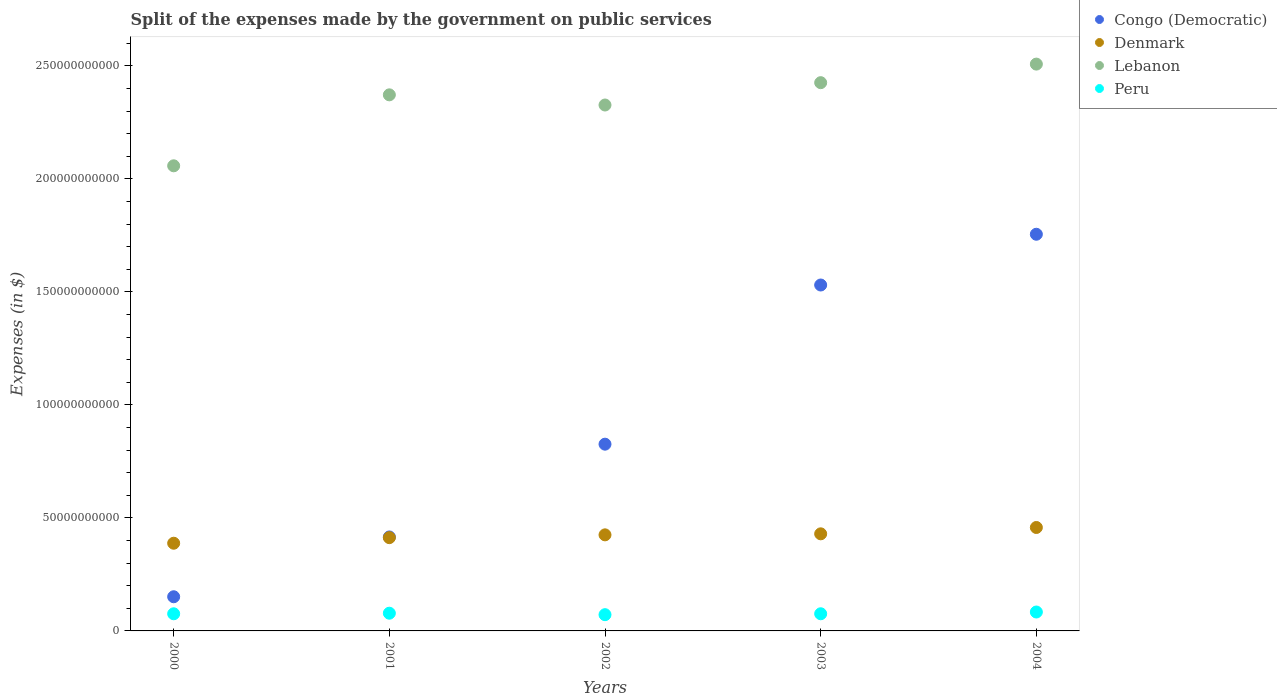Is the number of dotlines equal to the number of legend labels?
Your answer should be very brief. Yes. What is the expenses made by the government on public services in Lebanon in 2000?
Keep it short and to the point. 2.06e+11. Across all years, what is the maximum expenses made by the government on public services in Denmark?
Your response must be concise. 4.58e+1. Across all years, what is the minimum expenses made by the government on public services in Denmark?
Give a very brief answer. 3.88e+1. In which year was the expenses made by the government on public services in Peru minimum?
Your answer should be compact. 2002. What is the total expenses made by the government on public services in Lebanon in the graph?
Ensure brevity in your answer.  1.17e+12. What is the difference between the expenses made by the government on public services in Congo (Democratic) in 2000 and that in 2001?
Your answer should be very brief. -2.65e+1. What is the difference between the expenses made by the government on public services in Denmark in 2002 and the expenses made by the government on public services in Lebanon in 2003?
Keep it short and to the point. -2.00e+11. What is the average expenses made by the government on public services in Denmark per year?
Keep it short and to the point. 4.23e+1. In the year 2002, what is the difference between the expenses made by the government on public services in Congo (Democratic) and expenses made by the government on public services in Denmark?
Make the answer very short. 4.01e+1. What is the ratio of the expenses made by the government on public services in Peru in 2000 to that in 2004?
Ensure brevity in your answer.  0.91. Is the difference between the expenses made by the government on public services in Congo (Democratic) in 2000 and 2001 greater than the difference between the expenses made by the government on public services in Denmark in 2000 and 2001?
Provide a short and direct response. No. What is the difference between the highest and the second highest expenses made by the government on public services in Lebanon?
Give a very brief answer. 8.22e+09. What is the difference between the highest and the lowest expenses made by the government on public services in Peru?
Your answer should be very brief. 1.18e+09. In how many years, is the expenses made by the government on public services in Peru greater than the average expenses made by the government on public services in Peru taken over all years?
Give a very brief answer. 2. Is the sum of the expenses made by the government on public services in Lebanon in 2000 and 2001 greater than the maximum expenses made by the government on public services in Peru across all years?
Your response must be concise. Yes. Does the expenses made by the government on public services in Congo (Democratic) monotonically increase over the years?
Provide a short and direct response. Yes. Is the expenses made by the government on public services in Peru strictly greater than the expenses made by the government on public services in Denmark over the years?
Your response must be concise. No. Is the expenses made by the government on public services in Denmark strictly less than the expenses made by the government on public services in Lebanon over the years?
Keep it short and to the point. Yes. How many years are there in the graph?
Provide a succinct answer. 5. Are the values on the major ticks of Y-axis written in scientific E-notation?
Offer a very short reply. No. Does the graph contain grids?
Your response must be concise. No. Where does the legend appear in the graph?
Your answer should be compact. Top right. How many legend labels are there?
Ensure brevity in your answer.  4. How are the legend labels stacked?
Your response must be concise. Vertical. What is the title of the graph?
Provide a short and direct response. Split of the expenses made by the government on public services. What is the label or title of the Y-axis?
Your answer should be very brief. Expenses (in $). What is the Expenses (in $) in Congo (Democratic) in 2000?
Ensure brevity in your answer.  1.51e+1. What is the Expenses (in $) of Denmark in 2000?
Keep it short and to the point. 3.88e+1. What is the Expenses (in $) in Lebanon in 2000?
Provide a succinct answer. 2.06e+11. What is the Expenses (in $) of Peru in 2000?
Offer a very short reply. 7.58e+09. What is the Expenses (in $) of Congo (Democratic) in 2001?
Your answer should be compact. 4.16e+1. What is the Expenses (in $) of Denmark in 2001?
Keep it short and to the point. 4.13e+1. What is the Expenses (in $) in Lebanon in 2001?
Give a very brief answer. 2.37e+11. What is the Expenses (in $) in Peru in 2001?
Give a very brief answer. 7.84e+09. What is the Expenses (in $) of Congo (Democratic) in 2002?
Keep it short and to the point. 8.26e+1. What is the Expenses (in $) of Denmark in 2002?
Your answer should be compact. 4.25e+1. What is the Expenses (in $) of Lebanon in 2002?
Give a very brief answer. 2.33e+11. What is the Expenses (in $) in Peru in 2002?
Your answer should be very brief. 7.19e+09. What is the Expenses (in $) of Congo (Democratic) in 2003?
Ensure brevity in your answer.  1.53e+11. What is the Expenses (in $) in Denmark in 2003?
Ensure brevity in your answer.  4.30e+1. What is the Expenses (in $) of Lebanon in 2003?
Offer a very short reply. 2.43e+11. What is the Expenses (in $) of Peru in 2003?
Offer a terse response. 7.59e+09. What is the Expenses (in $) in Congo (Democratic) in 2004?
Make the answer very short. 1.76e+11. What is the Expenses (in $) in Denmark in 2004?
Ensure brevity in your answer.  4.58e+1. What is the Expenses (in $) of Lebanon in 2004?
Provide a short and direct response. 2.51e+11. What is the Expenses (in $) in Peru in 2004?
Your response must be concise. 8.37e+09. Across all years, what is the maximum Expenses (in $) in Congo (Democratic)?
Your response must be concise. 1.76e+11. Across all years, what is the maximum Expenses (in $) of Denmark?
Ensure brevity in your answer.  4.58e+1. Across all years, what is the maximum Expenses (in $) in Lebanon?
Offer a very short reply. 2.51e+11. Across all years, what is the maximum Expenses (in $) of Peru?
Provide a succinct answer. 8.37e+09. Across all years, what is the minimum Expenses (in $) in Congo (Democratic)?
Make the answer very short. 1.51e+1. Across all years, what is the minimum Expenses (in $) in Denmark?
Provide a succinct answer. 3.88e+1. Across all years, what is the minimum Expenses (in $) of Lebanon?
Provide a succinct answer. 2.06e+11. Across all years, what is the minimum Expenses (in $) in Peru?
Offer a terse response. 7.19e+09. What is the total Expenses (in $) in Congo (Democratic) in the graph?
Your answer should be very brief. 4.68e+11. What is the total Expenses (in $) of Denmark in the graph?
Your answer should be very brief. 2.11e+11. What is the total Expenses (in $) in Lebanon in the graph?
Provide a succinct answer. 1.17e+12. What is the total Expenses (in $) of Peru in the graph?
Provide a short and direct response. 3.86e+1. What is the difference between the Expenses (in $) of Congo (Democratic) in 2000 and that in 2001?
Offer a very short reply. -2.65e+1. What is the difference between the Expenses (in $) in Denmark in 2000 and that in 2001?
Offer a terse response. -2.47e+09. What is the difference between the Expenses (in $) in Lebanon in 2000 and that in 2001?
Ensure brevity in your answer.  -3.14e+1. What is the difference between the Expenses (in $) of Peru in 2000 and that in 2001?
Give a very brief answer. -2.54e+08. What is the difference between the Expenses (in $) in Congo (Democratic) in 2000 and that in 2002?
Offer a terse response. -6.75e+1. What is the difference between the Expenses (in $) in Denmark in 2000 and that in 2002?
Ensure brevity in your answer.  -3.71e+09. What is the difference between the Expenses (in $) of Lebanon in 2000 and that in 2002?
Your answer should be compact. -2.69e+1. What is the difference between the Expenses (in $) in Peru in 2000 and that in 2002?
Provide a short and direct response. 3.95e+08. What is the difference between the Expenses (in $) in Congo (Democratic) in 2000 and that in 2003?
Ensure brevity in your answer.  -1.38e+11. What is the difference between the Expenses (in $) in Denmark in 2000 and that in 2003?
Keep it short and to the point. -4.16e+09. What is the difference between the Expenses (in $) in Lebanon in 2000 and that in 2003?
Provide a short and direct response. -3.68e+1. What is the difference between the Expenses (in $) in Peru in 2000 and that in 2003?
Your answer should be compact. -6.50e+06. What is the difference between the Expenses (in $) of Congo (Democratic) in 2000 and that in 2004?
Provide a short and direct response. -1.60e+11. What is the difference between the Expenses (in $) of Denmark in 2000 and that in 2004?
Provide a succinct answer. -6.96e+09. What is the difference between the Expenses (in $) of Lebanon in 2000 and that in 2004?
Give a very brief answer. -4.50e+1. What is the difference between the Expenses (in $) in Peru in 2000 and that in 2004?
Offer a terse response. -7.84e+08. What is the difference between the Expenses (in $) in Congo (Democratic) in 2001 and that in 2002?
Provide a short and direct response. -4.11e+1. What is the difference between the Expenses (in $) in Denmark in 2001 and that in 2002?
Provide a short and direct response. -1.24e+09. What is the difference between the Expenses (in $) in Lebanon in 2001 and that in 2002?
Your response must be concise. 4.50e+09. What is the difference between the Expenses (in $) in Peru in 2001 and that in 2002?
Provide a short and direct response. 6.49e+08. What is the difference between the Expenses (in $) in Congo (Democratic) in 2001 and that in 2003?
Provide a short and direct response. -1.11e+11. What is the difference between the Expenses (in $) of Denmark in 2001 and that in 2003?
Provide a short and direct response. -1.69e+09. What is the difference between the Expenses (in $) of Lebanon in 2001 and that in 2003?
Give a very brief answer. -5.38e+09. What is the difference between the Expenses (in $) in Peru in 2001 and that in 2003?
Offer a very short reply. 2.48e+08. What is the difference between the Expenses (in $) of Congo (Democratic) in 2001 and that in 2004?
Ensure brevity in your answer.  -1.34e+11. What is the difference between the Expenses (in $) of Denmark in 2001 and that in 2004?
Offer a very short reply. -4.50e+09. What is the difference between the Expenses (in $) of Lebanon in 2001 and that in 2004?
Offer a very short reply. -1.36e+1. What is the difference between the Expenses (in $) in Peru in 2001 and that in 2004?
Make the answer very short. -5.30e+08. What is the difference between the Expenses (in $) of Congo (Democratic) in 2002 and that in 2003?
Your answer should be compact. -7.04e+1. What is the difference between the Expenses (in $) of Denmark in 2002 and that in 2003?
Ensure brevity in your answer.  -4.53e+08. What is the difference between the Expenses (in $) in Lebanon in 2002 and that in 2003?
Your answer should be very brief. -9.88e+09. What is the difference between the Expenses (in $) in Peru in 2002 and that in 2003?
Provide a succinct answer. -4.01e+08. What is the difference between the Expenses (in $) in Congo (Democratic) in 2002 and that in 2004?
Offer a very short reply. -9.29e+1. What is the difference between the Expenses (in $) in Denmark in 2002 and that in 2004?
Ensure brevity in your answer.  -3.26e+09. What is the difference between the Expenses (in $) of Lebanon in 2002 and that in 2004?
Ensure brevity in your answer.  -1.81e+1. What is the difference between the Expenses (in $) in Peru in 2002 and that in 2004?
Ensure brevity in your answer.  -1.18e+09. What is the difference between the Expenses (in $) of Congo (Democratic) in 2003 and that in 2004?
Provide a short and direct response. -2.25e+1. What is the difference between the Expenses (in $) of Denmark in 2003 and that in 2004?
Offer a terse response. -2.80e+09. What is the difference between the Expenses (in $) in Lebanon in 2003 and that in 2004?
Provide a short and direct response. -8.22e+09. What is the difference between the Expenses (in $) in Peru in 2003 and that in 2004?
Provide a short and direct response. -7.78e+08. What is the difference between the Expenses (in $) of Congo (Democratic) in 2000 and the Expenses (in $) of Denmark in 2001?
Provide a succinct answer. -2.62e+1. What is the difference between the Expenses (in $) in Congo (Democratic) in 2000 and the Expenses (in $) in Lebanon in 2001?
Keep it short and to the point. -2.22e+11. What is the difference between the Expenses (in $) of Congo (Democratic) in 2000 and the Expenses (in $) of Peru in 2001?
Ensure brevity in your answer.  7.28e+09. What is the difference between the Expenses (in $) of Denmark in 2000 and the Expenses (in $) of Lebanon in 2001?
Provide a succinct answer. -1.98e+11. What is the difference between the Expenses (in $) of Denmark in 2000 and the Expenses (in $) of Peru in 2001?
Give a very brief answer. 3.10e+1. What is the difference between the Expenses (in $) in Lebanon in 2000 and the Expenses (in $) in Peru in 2001?
Provide a short and direct response. 1.98e+11. What is the difference between the Expenses (in $) in Congo (Democratic) in 2000 and the Expenses (in $) in Denmark in 2002?
Your answer should be compact. -2.74e+1. What is the difference between the Expenses (in $) in Congo (Democratic) in 2000 and the Expenses (in $) in Lebanon in 2002?
Provide a succinct answer. -2.18e+11. What is the difference between the Expenses (in $) of Congo (Democratic) in 2000 and the Expenses (in $) of Peru in 2002?
Keep it short and to the point. 7.93e+09. What is the difference between the Expenses (in $) in Denmark in 2000 and the Expenses (in $) in Lebanon in 2002?
Keep it short and to the point. -1.94e+11. What is the difference between the Expenses (in $) of Denmark in 2000 and the Expenses (in $) of Peru in 2002?
Your response must be concise. 3.16e+1. What is the difference between the Expenses (in $) of Lebanon in 2000 and the Expenses (in $) of Peru in 2002?
Your response must be concise. 1.99e+11. What is the difference between the Expenses (in $) of Congo (Democratic) in 2000 and the Expenses (in $) of Denmark in 2003?
Ensure brevity in your answer.  -2.78e+1. What is the difference between the Expenses (in $) of Congo (Democratic) in 2000 and the Expenses (in $) of Lebanon in 2003?
Your answer should be very brief. -2.27e+11. What is the difference between the Expenses (in $) of Congo (Democratic) in 2000 and the Expenses (in $) of Peru in 2003?
Your response must be concise. 7.53e+09. What is the difference between the Expenses (in $) in Denmark in 2000 and the Expenses (in $) in Lebanon in 2003?
Your answer should be compact. -2.04e+11. What is the difference between the Expenses (in $) of Denmark in 2000 and the Expenses (in $) of Peru in 2003?
Provide a short and direct response. 3.12e+1. What is the difference between the Expenses (in $) in Lebanon in 2000 and the Expenses (in $) in Peru in 2003?
Your answer should be very brief. 1.98e+11. What is the difference between the Expenses (in $) in Congo (Democratic) in 2000 and the Expenses (in $) in Denmark in 2004?
Provide a short and direct response. -3.06e+1. What is the difference between the Expenses (in $) in Congo (Democratic) in 2000 and the Expenses (in $) in Lebanon in 2004?
Provide a succinct answer. -2.36e+11. What is the difference between the Expenses (in $) of Congo (Democratic) in 2000 and the Expenses (in $) of Peru in 2004?
Your answer should be very brief. 6.75e+09. What is the difference between the Expenses (in $) in Denmark in 2000 and the Expenses (in $) in Lebanon in 2004?
Provide a succinct answer. -2.12e+11. What is the difference between the Expenses (in $) of Denmark in 2000 and the Expenses (in $) of Peru in 2004?
Your answer should be compact. 3.04e+1. What is the difference between the Expenses (in $) of Lebanon in 2000 and the Expenses (in $) of Peru in 2004?
Offer a very short reply. 1.97e+11. What is the difference between the Expenses (in $) of Congo (Democratic) in 2001 and the Expenses (in $) of Denmark in 2002?
Offer a very short reply. -9.29e+08. What is the difference between the Expenses (in $) in Congo (Democratic) in 2001 and the Expenses (in $) in Lebanon in 2002?
Offer a terse response. -1.91e+11. What is the difference between the Expenses (in $) in Congo (Democratic) in 2001 and the Expenses (in $) in Peru in 2002?
Offer a very short reply. 3.44e+1. What is the difference between the Expenses (in $) of Denmark in 2001 and the Expenses (in $) of Lebanon in 2002?
Your answer should be very brief. -1.91e+11. What is the difference between the Expenses (in $) in Denmark in 2001 and the Expenses (in $) in Peru in 2002?
Keep it short and to the point. 3.41e+1. What is the difference between the Expenses (in $) of Lebanon in 2001 and the Expenses (in $) of Peru in 2002?
Give a very brief answer. 2.30e+11. What is the difference between the Expenses (in $) of Congo (Democratic) in 2001 and the Expenses (in $) of Denmark in 2003?
Make the answer very short. -1.38e+09. What is the difference between the Expenses (in $) in Congo (Democratic) in 2001 and the Expenses (in $) in Lebanon in 2003?
Your answer should be very brief. -2.01e+11. What is the difference between the Expenses (in $) in Congo (Democratic) in 2001 and the Expenses (in $) in Peru in 2003?
Provide a short and direct response. 3.40e+1. What is the difference between the Expenses (in $) in Denmark in 2001 and the Expenses (in $) in Lebanon in 2003?
Your response must be concise. -2.01e+11. What is the difference between the Expenses (in $) in Denmark in 2001 and the Expenses (in $) in Peru in 2003?
Your answer should be compact. 3.37e+1. What is the difference between the Expenses (in $) in Lebanon in 2001 and the Expenses (in $) in Peru in 2003?
Make the answer very short. 2.30e+11. What is the difference between the Expenses (in $) in Congo (Democratic) in 2001 and the Expenses (in $) in Denmark in 2004?
Provide a short and direct response. -4.19e+09. What is the difference between the Expenses (in $) in Congo (Democratic) in 2001 and the Expenses (in $) in Lebanon in 2004?
Offer a terse response. -2.09e+11. What is the difference between the Expenses (in $) in Congo (Democratic) in 2001 and the Expenses (in $) in Peru in 2004?
Make the answer very short. 3.32e+1. What is the difference between the Expenses (in $) of Denmark in 2001 and the Expenses (in $) of Lebanon in 2004?
Ensure brevity in your answer.  -2.10e+11. What is the difference between the Expenses (in $) of Denmark in 2001 and the Expenses (in $) of Peru in 2004?
Provide a short and direct response. 3.29e+1. What is the difference between the Expenses (in $) of Lebanon in 2001 and the Expenses (in $) of Peru in 2004?
Your response must be concise. 2.29e+11. What is the difference between the Expenses (in $) of Congo (Democratic) in 2002 and the Expenses (in $) of Denmark in 2003?
Your answer should be very brief. 3.97e+1. What is the difference between the Expenses (in $) of Congo (Democratic) in 2002 and the Expenses (in $) of Lebanon in 2003?
Provide a succinct answer. -1.60e+11. What is the difference between the Expenses (in $) in Congo (Democratic) in 2002 and the Expenses (in $) in Peru in 2003?
Your answer should be compact. 7.50e+1. What is the difference between the Expenses (in $) in Denmark in 2002 and the Expenses (in $) in Lebanon in 2003?
Keep it short and to the point. -2.00e+11. What is the difference between the Expenses (in $) of Denmark in 2002 and the Expenses (in $) of Peru in 2003?
Offer a terse response. 3.49e+1. What is the difference between the Expenses (in $) in Lebanon in 2002 and the Expenses (in $) in Peru in 2003?
Make the answer very short. 2.25e+11. What is the difference between the Expenses (in $) in Congo (Democratic) in 2002 and the Expenses (in $) in Denmark in 2004?
Provide a succinct answer. 3.69e+1. What is the difference between the Expenses (in $) of Congo (Democratic) in 2002 and the Expenses (in $) of Lebanon in 2004?
Ensure brevity in your answer.  -1.68e+11. What is the difference between the Expenses (in $) in Congo (Democratic) in 2002 and the Expenses (in $) in Peru in 2004?
Provide a short and direct response. 7.43e+1. What is the difference between the Expenses (in $) of Denmark in 2002 and the Expenses (in $) of Lebanon in 2004?
Your response must be concise. -2.08e+11. What is the difference between the Expenses (in $) of Denmark in 2002 and the Expenses (in $) of Peru in 2004?
Provide a succinct answer. 3.41e+1. What is the difference between the Expenses (in $) of Lebanon in 2002 and the Expenses (in $) of Peru in 2004?
Your answer should be compact. 2.24e+11. What is the difference between the Expenses (in $) in Congo (Democratic) in 2003 and the Expenses (in $) in Denmark in 2004?
Your answer should be very brief. 1.07e+11. What is the difference between the Expenses (in $) in Congo (Democratic) in 2003 and the Expenses (in $) in Lebanon in 2004?
Ensure brevity in your answer.  -9.77e+1. What is the difference between the Expenses (in $) of Congo (Democratic) in 2003 and the Expenses (in $) of Peru in 2004?
Ensure brevity in your answer.  1.45e+11. What is the difference between the Expenses (in $) in Denmark in 2003 and the Expenses (in $) in Lebanon in 2004?
Give a very brief answer. -2.08e+11. What is the difference between the Expenses (in $) in Denmark in 2003 and the Expenses (in $) in Peru in 2004?
Your response must be concise. 3.46e+1. What is the difference between the Expenses (in $) of Lebanon in 2003 and the Expenses (in $) of Peru in 2004?
Provide a short and direct response. 2.34e+11. What is the average Expenses (in $) in Congo (Democratic) per year?
Keep it short and to the point. 9.36e+1. What is the average Expenses (in $) of Denmark per year?
Offer a very short reply. 4.23e+1. What is the average Expenses (in $) of Lebanon per year?
Give a very brief answer. 2.34e+11. What is the average Expenses (in $) of Peru per year?
Ensure brevity in your answer.  7.71e+09. In the year 2000, what is the difference between the Expenses (in $) in Congo (Democratic) and Expenses (in $) in Denmark?
Your answer should be compact. -2.37e+1. In the year 2000, what is the difference between the Expenses (in $) in Congo (Democratic) and Expenses (in $) in Lebanon?
Provide a short and direct response. -1.91e+11. In the year 2000, what is the difference between the Expenses (in $) in Congo (Democratic) and Expenses (in $) in Peru?
Give a very brief answer. 7.53e+09. In the year 2000, what is the difference between the Expenses (in $) of Denmark and Expenses (in $) of Lebanon?
Provide a short and direct response. -1.67e+11. In the year 2000, what is the difference between the Expenses (in $) in Denmark and Expenses (in $) in Peru?
Your answer should be compact. 3.12e+1. In the year 2000, what is the difference between the Expenses (in $) in Lebanon and Expenses (in $) in Peru?
Offer a terse response. 1.98e+11. In the year 2001, what is the difference between the Expenses (in $) in Congo (Democratic) and Expenses (in $) in Denmark?
Give a very brief answer. 3.08e+08. In the year 2001, what is the difference between the Expenses (in $) of Congo (Democratic) and Expenses (in $) of Lebanon?
Offer a very short reply. -1.96e+11. In the year 2001, what is the difference between the Expenses (in $) of Congo (Democratic) and Expenses (in $) of Peru?
Ensure brevity in your answer.  3.37e+1. In the year 2001, what is the difference between the Expenses (in $) of Denmark and Expenses (in $) of Lebanon?
Offer a terse response. -1.96e+11. In the year 2001, what is the difference between the Expenses (in $) of Denmark and Expenses (in $) of Peru?
Provide a succinct answer. 3.34e+1. In the year 2001, what is the difference between the Expenses (in $) in Lebanon and Expenses (in $) in Peru?
Ensure brevity in your answer.  2.29e+11. In the year 2002, what is the difference between the Expenses (in $) in Congo (Democratic) and Expenses (in $) in Denmark?
Ensure brevity in your answer.  4.01e+1. In the year 2002, what is the difference between the Expenses (in $) of Congo (Democratic) and Expenses (in $) of Lebanon?
Your answer should be compact. -1.50e+11. In the year 2002, what is the difference between the Expenses (in $) of Congo (Democratic) and Expenses (in $) of Peru?
Your answer should be very brief. 7.54e+1. In the year 2002, what is the difference between the Expenses (in $) of Denmark and Expenses (in $) of Lebanon?
Your answer should be compact. -1.90e+11. In the year 2002, what is the difference between the Expenses (in $) in Denmark and Expenses (in $) in Peru?
Give a very brief answer. 3.53e+1. In the year 2002, what is the difference between the Expenses (in $) of Lebanon and Expenses (in $) of Peru?
Ensure brevity in your answer.  2.26e+11. In the year 2003, what is the difference between the Expenses (in $) in Congo (Democratic) and Expenses (in $) in Denmark?
Offer a terse response. 1.10e+11. In the year 2003, what is the difference between the Expenses (in $) of Congo (Democratic) and Expenses (in $) of Lebanon?
Provide a short and direct response. -8.95e+1. In the year 2003, what is the difference between the Expenses (in $) in Congo (Democratic) and Expenses (in $) in Peru?
Provide a succinct answer. 1.45e+11. In the year 2003, what is the difference between the Expenses (in $) in Denmark and Expenses (in $) in Lebanon?
Give a very brief answer. -2.00e+11. In the year 2003, what is the difference between the Expenses (in $) in Denmark and Expenses (in $) in Peru?
Your answer should be compact. 3.54e+1. In the year 2003, what is the difference between the Expenses (in $) in Lebanon and Expenses (in $) in Peru?
Make the answer very short. 2.35e+11. In the year 2004, what is the difference between the Expenses (in $) of Congo (Democratic) and Expenses (in $) of Denmark?
Your response must be concise. 1.30e+11. In the year 2004, what is the difference between the Expenses (in $) of Congo (Democratic) and Expenses (in $) of Lebanon?
Provide a succinct answer. -7.53e+1. In the year 2004, what is the difference between the Expenses (in $) in Congo (Democratic) and Expenses (in $) in Peru?
Give a very brief answer. 1.67e+11. In the year 2004, what is the difference between the Expenses (in $) of Denmark and Expenses (in $) of Lebanon?
Provide a short and direct response. -2.05e+11. In the year 2004, what is the difference between the Expenses (in $) in Denmark and Expenses (in $) in Peru?
Give a very brief answer. 3.74e+1. In the year 2004, what is the difference between the Expenses (in $) in Lebanon and Expenses (in $) in Peru?
Your answer should be very brief. 2.42e+11. What is the ratio of the Expenses (in $) of Congo (Democratic) in 2000 to that in 2001?
Offer a very short reply. 0.36. What is the ratio of the Expenses (in $) in Denmark in 2000 to that in 2001?
Your answer should be compact. 0.94. What is the ratio of the Expenses (in $) of Lebanon in 2000 to that in 2001?
Your answer should be very brief. 0.87. What is the ratio of the Expenses (in $) in Peru in 2000 to that in 2001?
Your answer should be compact. 0.97. What is the ratio of the Expenses (in $) in Congo (Democratic) in 2000 to that in 2002?
Provide a succinct answer. 0.18. What is the ratio of the Expenses (in $) in Denmark in 2000 to that in 2002?
Your answer should be very brief. 0.91. What is the ratio of the Expenses (in $) in Lebanon in 2000 to that in 2002?
Provide a short and direct response. 0.88. What is the ratio of the Expenses (in $) of Peru in 2000 to that in 2002?
Offer a terse response. 1.05. What is the ratio of the Expenses (in $) of Congo (Democratic) in 2000 to that in 2003?
Provide a short and direct response. 0.1. What is the ratio of the Expenses (in $) in Denmark in 2000 to that in 2003?
Make the answer very short. 0.9. What is the ratio of the Expenses (in $) of Lebanon in 2000 to that in 2003?
Your answer should be very brief. 0.85. What is the ratio of the Expenses (in $) in Congo (Democratic) in 2000 to that in 2004?
Your answer should be compact. 0.09. What is the ratio of the Expenses (in $) of Denmark in 2000 to that in 2004?
Keep it short and to the point. 0.85. What is the ratio of the Expenses (in $) in Lebanon in 2000 to that in 2004?
Offer a terse response. 0.82. What is the ratio of the Expenses (in $) in Peru in 2000 to that in 2004?
Give a very brief answer. 0.91. What is the ratio of the Expenses (in $) in Congo (Democratic) in 2001 to that in 2002?
Your response must be concise. 0.5. What is the ratio of the Expenses (in $) in Denmark in 2001 to that in 2002?
Keep it short and to the point. 0.97. What is the ratio of the Expenses (in $) of Lebanon in 2001 to that in 2002?
Make the answer very short. 1.02. What is the ratio of the Expenses (in $) in Peru in 2001 to that in 2002?
Your response must be concise. 1.09. What is the ratio of the Expenses (in $) of Congo (Democratic) in 2001 to that in 2003?
Give a very brief answer. 0.27. What is the ratio of the Expenses (in $) of Denmark in 2001 to that in 2003?
Make the answer very short. 0.96. What is the ratio of the Expenses (in $) of Lebanon in 2001 to that in 2003?
Ensure brevity in your answer.  0.98. What is the ratio of the Expenses (in $) of Peru in 2001 to that in 2003?
Your answer should be compact. 1.03. What is the ratio of the Expenses (in $) of Congo (Democratic) in 2001 to that in 2004?
Give a very brief answer. 0.24. What is the ratio of the Expenses (in $) of Denmark in 2001 to that in 2004?
Your answer should be compact. 0.9. What is the ratio of the Expenses (in $) in Lebanon in 2001 to that in 2004?
Your answer should be compact. 0.95. What is the ratio of the Expenses (in $) in Peru in 2001 to that in 2004?
Ensure brevity in your answer.  0.94. What is the ratio of the Expenses (in $) of Congo (Democratic) in 2002 to that in 2003?
Provide a succinct answer. 0.54. What is the ratio of the Expenses (in $) in Denmark in 2002 to that in 2003?
Provide a succinct answer. 0.99. What is the ratio of the Expenses (in $) of Lebanon in 2002 to that in 2003?
Ensure brevity in your answer.  0.96. What is the ratio of the Expenses (in $) in Peru in 2002 to that in 2003?
Your response must be concise. 0.95. What is the ratio of the Expenses (in $) in Congo (Democratic) in 2002 to that in 2004?
Give a very brief answer. 0.47. What is the ratio of the Expenses (in $) in Denmark in 2002 to that in 2004?
Your response must be concise. 0.93. What is the ratio of the Expenses (in $) in Lebanon in 2002 to that in 2004?
Provide a succinct answer. 0.93. What is the ratio of the Expenses (in $) of Peru in 2002 to that in 2004?
Give a very brief answer. 0.86. What is the ratio of the Expenses (in $) in Congo (Democratic) in 2003 to that in 2004?
Give a very brief answer. 0.87. What is the ratio of the Expenses (in $) in Denmark in 2003 to that in 2004?
Provide a short and direct response. 0.94. What is the ratio of the Expenses (in $) of Lebanon in 2003 to that in 2004?
Provide a short and direct response. 0.97. What is the ratio of the Expenses (in $) in Peru in 2003 to that in 2004?
Keep it short and to the point. 0.91. What is the difference between the highest and the second highest Expenses (in $) of Congo (Democratic)?
Keep it short and to the point. 2.25e+1. What is the difference between the highest and the second highest Expenses (in $) in Denmark?
Give a very brief answer. 2.80e+09. What is the difference between the highest and the second highest Expenses (in $) in Lebanon?
Give a very brief answer. 8.22e+09. What is the difference between the highest and the second highest Expenses (in $) in Peru?
Offer a terse response. 5.30e+08. What is the difference between the highest and the lowest Expenses (in $) in Congo (Democratic)?
Keep it short and to the point. 1.60e+11. What is the difference between the highest and the lowest Expenses (in $) in Denmark?
Ensure brevity in your answer.  6.96e+09. What is the difference between the highest and the lowest Expenses (in $) in Lebanon?
Ensure brevity in your answer.  4.50e+1. What is the difference between the highest and the lowest Expenses (in $) of Peru?
Offer a very short reply. 1.18e+09. 